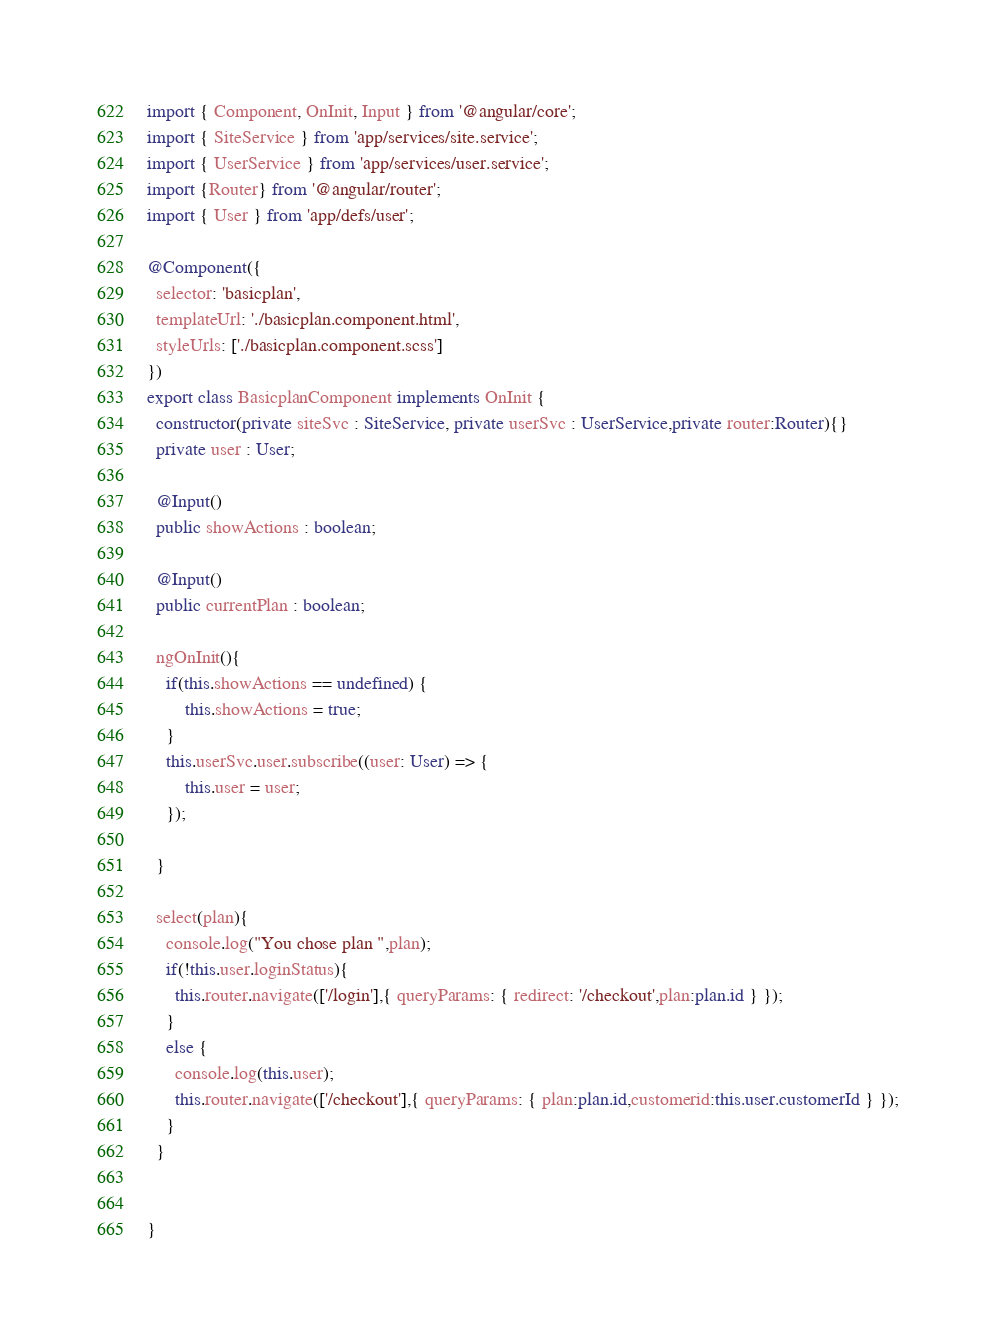Convert code to text. <code><loc_0><loc_0><loc_500><loc_500><_TypeScript_>import { Component, OnInit, Input } from '@angular/core';
import { SiteService } from 'app/services/site.service';
import { UserService } from 'app/services/user.service';
import {Router} from '@angular/router';
import { User } from 'app/defs/user';

@Component({
  selector: 'basicplan',
  templateUrl: './basicplan.component.html',
  styleUrls: ['./basicplan.component.scss']
})
export class BasicplanComponent implements OnInit {
  constructor(private siteSvc : SiteService, private userSvc : UserService,private router:Router){}
  private user : User;

  @Input()
  public showActions : boolean;

  @Input()
  public currentPlan : boolean;

  ngOnInit(){
  	if(this.showActions == undefined) {
  		this.showActions = true;
  	}
    this.userSvc.user.subscribe((user: User) => {
    	this.user = user;
    });

  }

  select(plan){
    console.log("You chose plan ",plan);
    if(!this.user.loginStatus){
      this.router.navigate(['/login'],{ queryParams: { redirect: '/checkout',plan:plan.id } });
    }
    else {
      console.log(this.user);
      this.router.navigate(['/checkout'],{ queryParams: { plan:plan.id,customerid:this.user.customerId } });
    }
  }


}
</code> 